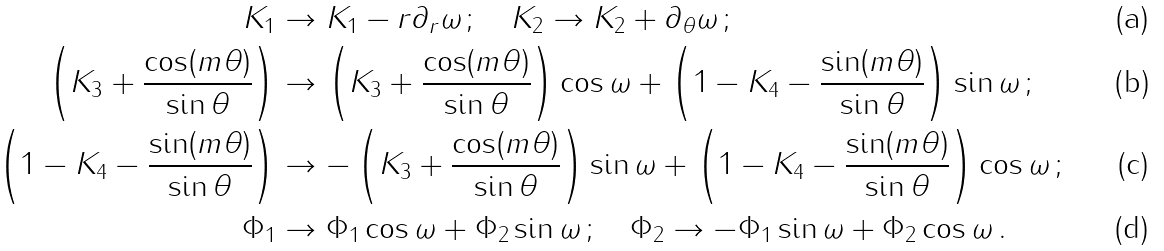<formula> <loc_0><loc_0><loc_500><loc_500>K _ { 1 } & \to K _ { 1 } - r \partial _ { r } \omega \, ; \quad K _ { 2 } \to K _ { 2 } + \partial _ { \theta } \omega \, ; \\ \left ( K _ { 3 } + \frac { \cos ( m \theta ) } { \sin \theta } \right ) & \to \left ( K _ { 3 } + \frac { \cos ( m \theta ) } { \sin \theta } \right ) \cos \omega + \left ( 1 - K _ { 4 } - \frac { \sin ( m \theta ) } { \sin \theta } \right ) \sin \omega \, ; \\ \left ( 1 - K _ { 4 } - \frac { \sin ( m \theta ) } { \sin \theta } \right ) & \to - \left ( K _ { 3 } + \frac { \cos ( m \theta ) } { \sin \theta } \right ) \sin \omega + \left ( 1 - K _ { 4 } - \frac { \sin ( m \theta ) } { \sin \theta } \right ) \cos \omega \, ; \\ \Phi _ { 1 } & \to \Phi _ { 1 } \cos \omega + \Phi _ { 2 } \sin \omega \, ; \quad \Phi _ { 2 } \to - \Phi _ { 1 } \sin \omega + \Phi _ { 2 } \cos \omega \, .</formula> 